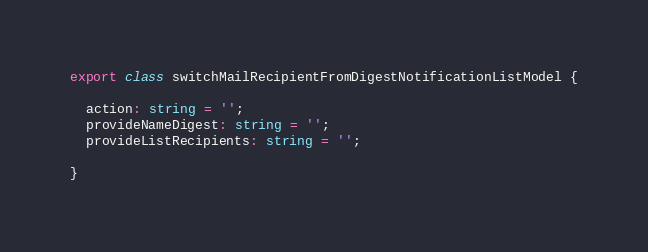<code> <loc_0><loc_0><loc_500><loc_500><_TypeScript_>export class switchMailRecipientFromDigestNotificationListModel {

  action: string = '';
  provideNameDigest: string = '';
  provideListRecipients: string = '';

}
</code> 